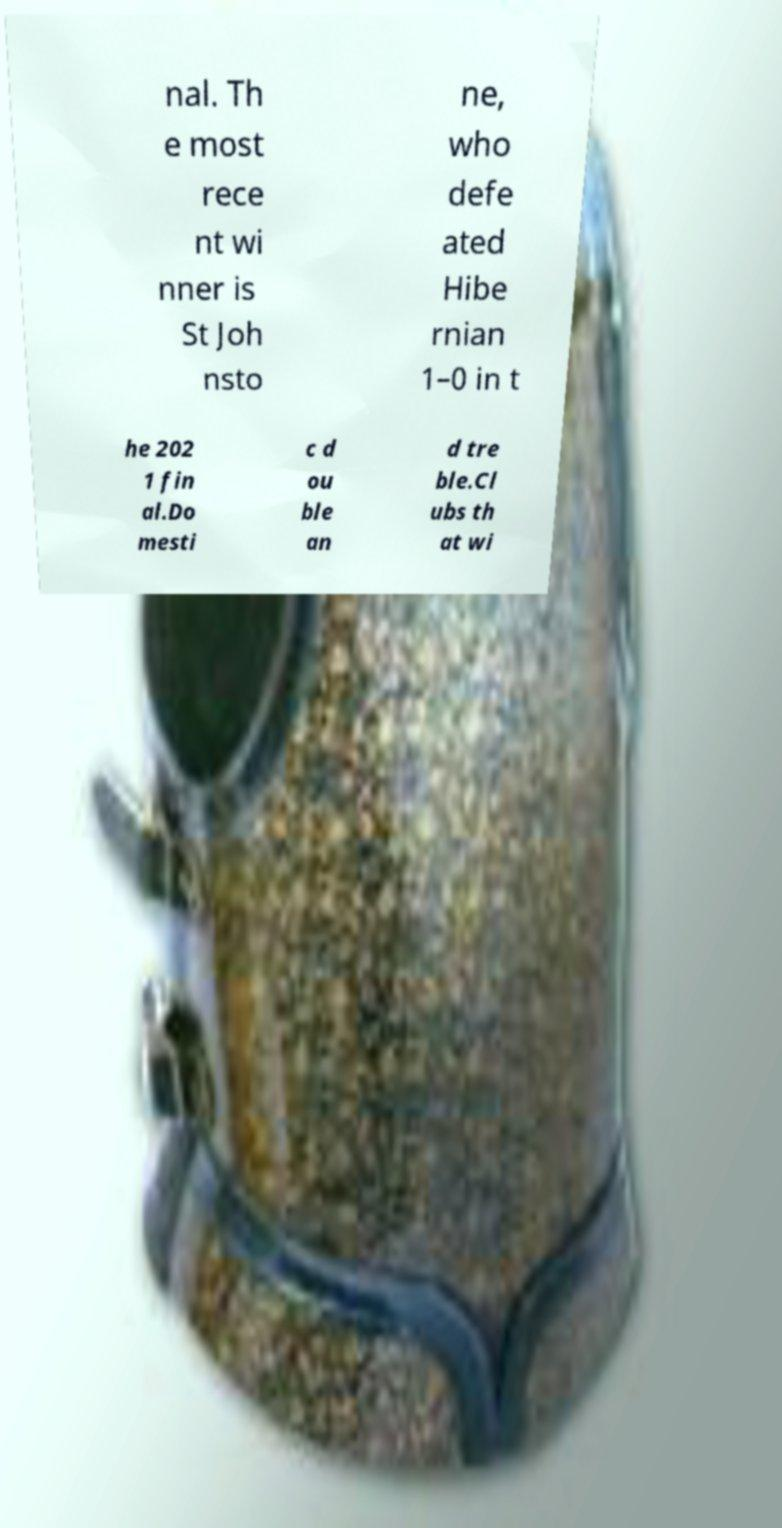Can you read and provide the text displayed in the image?This photo seems to have some interesting text. Can you extract and type it out for me? nal. Th e most rece nt wi nner is St Joh nsto ne, who defe ated Hibe rnian 1–0 in t he 202 1 fin al.Do mesti c d ou ble an d tre ble.Cl ubs th at wi 